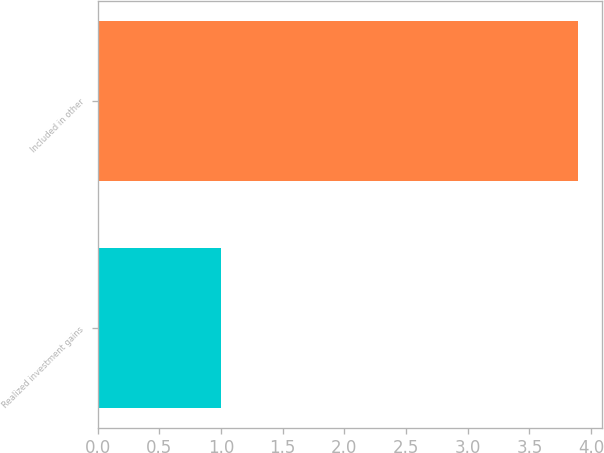Convert chart. <chart><loc_0><loc_0><loc_500><loc_500><bar_chart><fcel>Realized investment gains<fcel>Included in other<nl><fcel>1<fcel>3.89<nl></chart> 